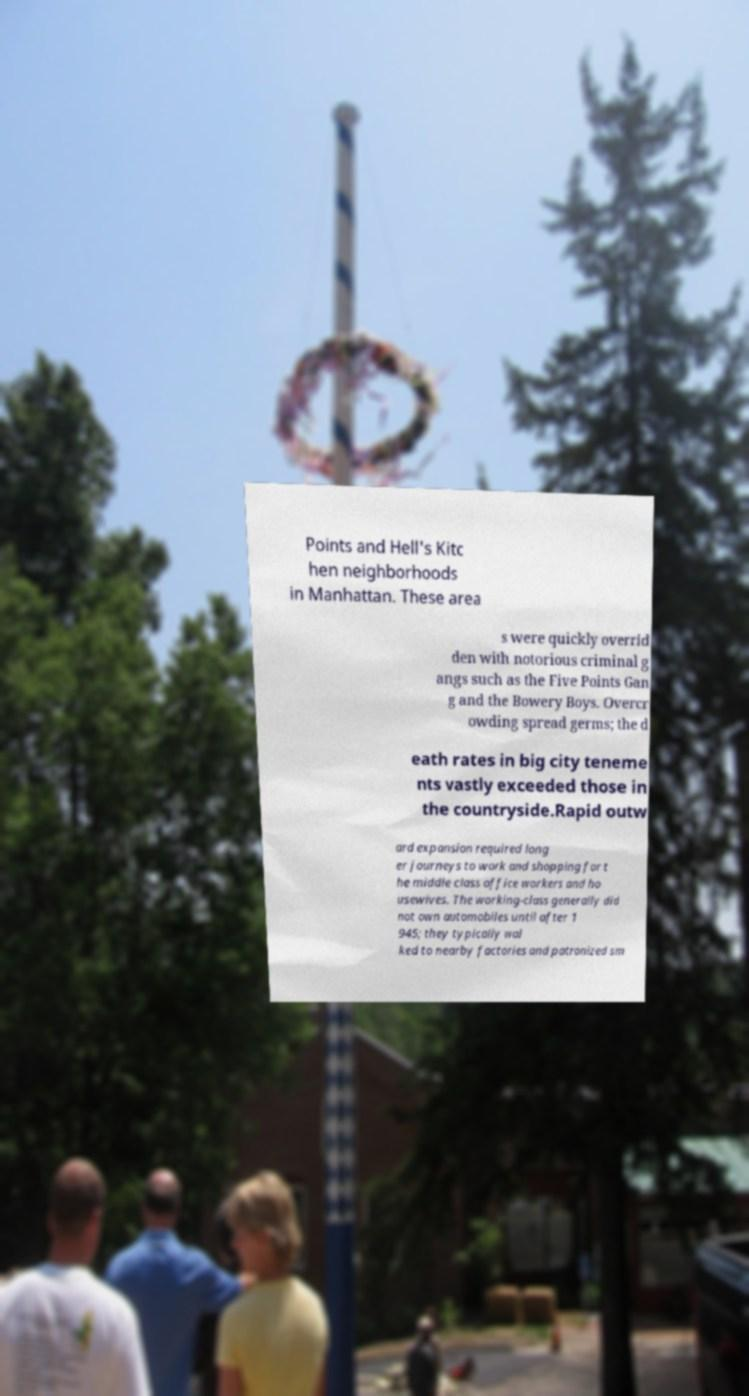Can you accurately transcribe the text from the provided image for me? Points and Hell's Kitc hen neighborhoods in Manhattan. These area s were quickly overrid den with notorious criminal g angs such as the Five Points Gan g and the Bowery Boys. Overcr owding spread germs; the d eath rates in big city teneme nts vastly exceeded those in the countryside.Rapid outw ard expansion required long er journeys to work and shopping for t he middle class office workers and ho usewives. The working-class generally did not own automobiles until after 1 945; they typically wal ked to nearby factories and patronized sm 